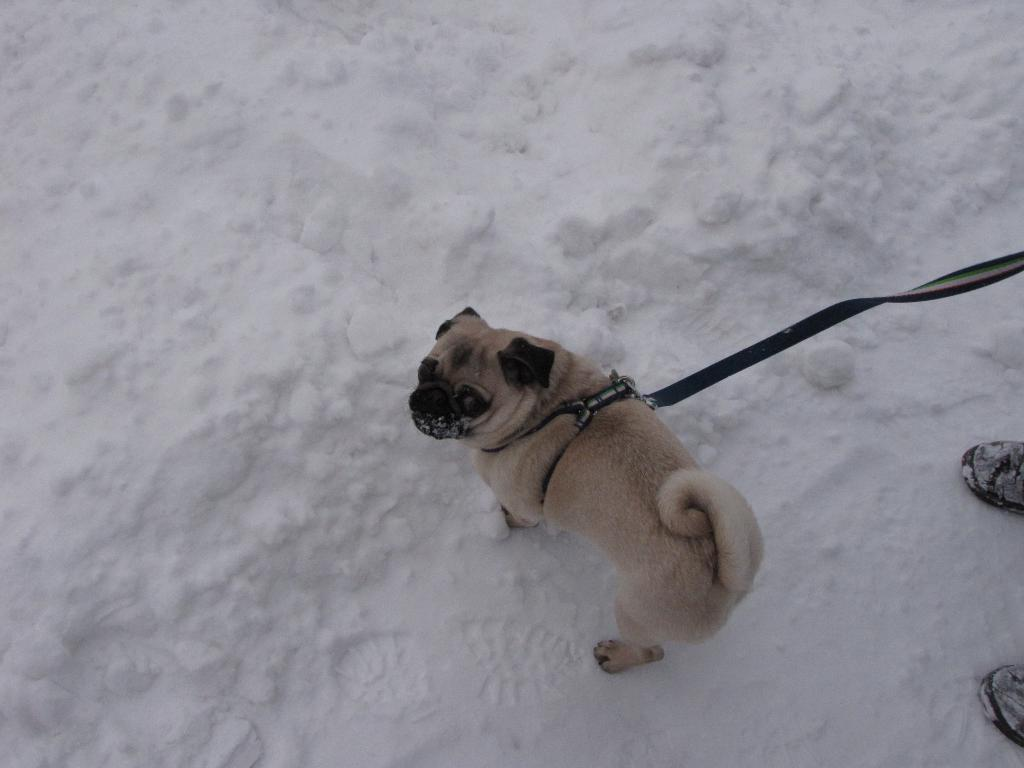What type of animal is in the image? There is a dog in the image. What colors can be seen on the dog? The dog is cream and black in color. Is the dog wearing any accessory in the image? Yes, the dog has a collar on its neck. What is attached to the dog's collar? There is a rope tied to the collar. What is the setting of the image? There is white snow visible in the image. How many horses are present in the image? There are no horses present in the image; it features a dog. What type of cap is the dog wearing in the image? There is no cap visible in the image; the dog is wearing a collar with a rope tied to it. 